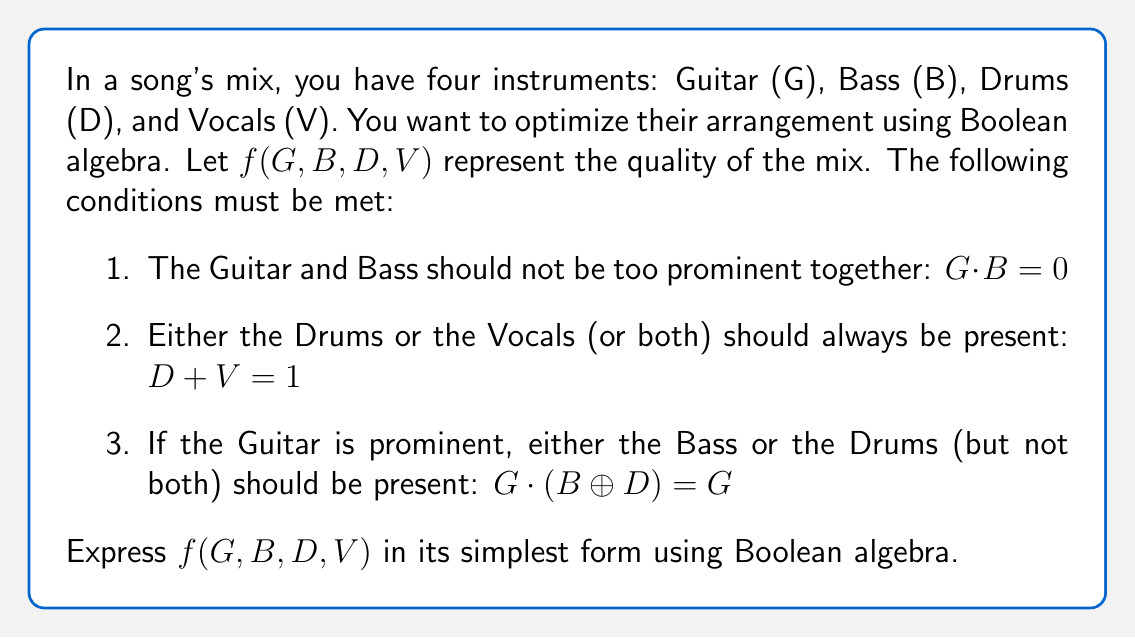Give your solution to this math problem. Let's approach this step-by-step:

1) First, we need to combine all the given conditions using the AND operator:

   $f(G,B,D,V) = (G \cdot B)' \cdot (D + V) \cdot (G' + (B \oplus D))$

2) Let's simplify each part:
   
   a) $(G \cdot B)' = G' + B'$ (De Morgan's Law)
   
   b) $(D + V)$ is already in its simplest form
   
   c) $(G' + (B \oplus D)) = G' + (B \cdot D' + B' \cdot D)$

3) Now, our function looks like this:

   $f(G,B,D,V) = (G' + B') \cdot (D + V) \cdot (G' + B \cdot D' + B' \cdot D)$

4) Distribute the terms:

   $f(G,B,D,V) = (G'D + G'V + B'D + B'V) \cdot (G' + B \cdot D' + B' \cdot D)$

5) Multiply out the terms:

   $f(G,B,D,V) = G'D \cdot G' + G'D \cdot B \cdot D' + G'D \cdot B' \cdot D + 
                  G'V \cdot G' + G'V \cdot B \cdot D' + G'V \cdot B' \cdot D + 
                  B'D \cdot G' + B'D \cdot B \cdot D' + B'D \cdot B' \cdot D + 
                  B'V \cdot G' + B'V \cdot B \cdot D' + B'V \cdot B' \cdot D$

6) Simplify:
   - $G' \cdot G' = G'$
   - $B' \cdot B = 0$
   - $D \cdot D' = 0$

   $f(G,B,D,V) = G'D + G'V + B'D \cdot G' + B'V \cdot G'$

7) Factor out $G'$:

   $f(G,B,D,V) = G' \cdot (D + V + B'D + B'V)$

8) Simplify inside the parentheses:

   $f(G,B,D,V) = G' \cdot (D + V)$

This is the simplest form of the function.
Answer: $G' \cdot (D + V)$ 